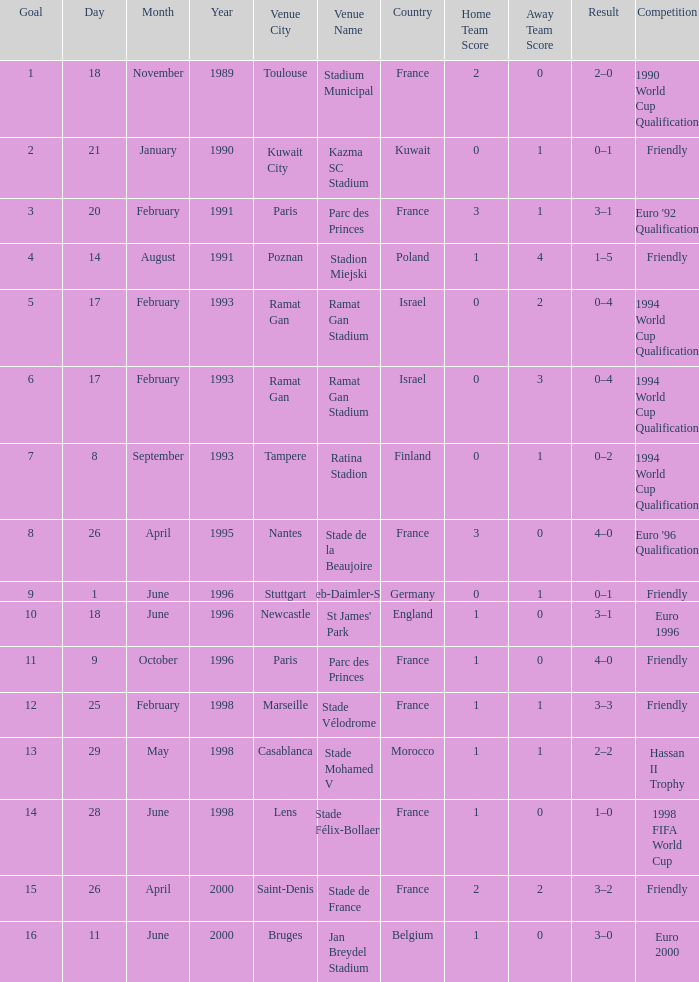What was the date of the game with a result of 3–2? 26 April 2000. 